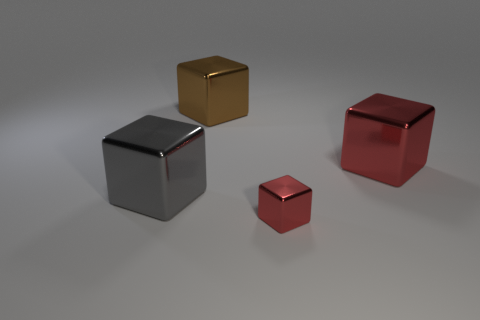Add 2 large shiny blocks. How many objects exist? 6 Subtract all gray shiny blocks. How many blocks are left? 3 Subtract all brown cubes. How many cubes are left? 3 Subtract all brown cylinders. How many red cubes are left? 2 Add 2 gray objects. How many gray objects are left? 3 Add 4 large red things. How many large red things exist? 5 Subtract 2 red cubes. How many objects are left? 2 Subtract 1 blocks. How many blocks are left? 3 Subtract all cyan cubes. Subtract all purple cylinders. How many cubes are left? 4 Subtract all tiny red matte things. Subtract all tiny red blocks. How many objects are left? 3 